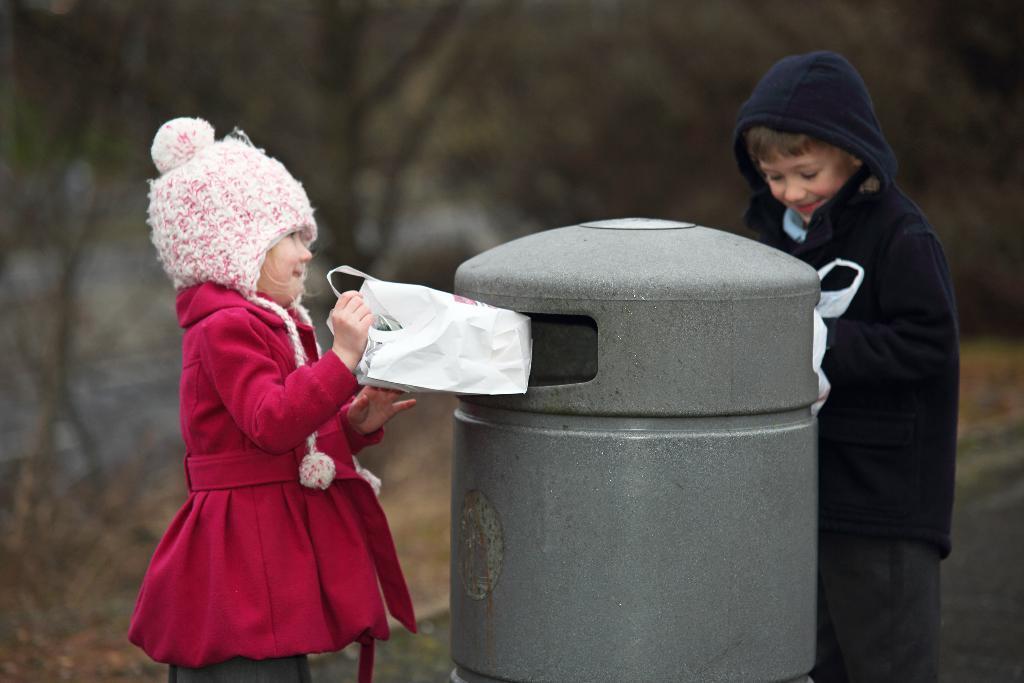Please provide a concise description of this image. In this image I can see 2 children standing, holding polythene covers. There is a cylindrical object in between them. The background is blurred. 